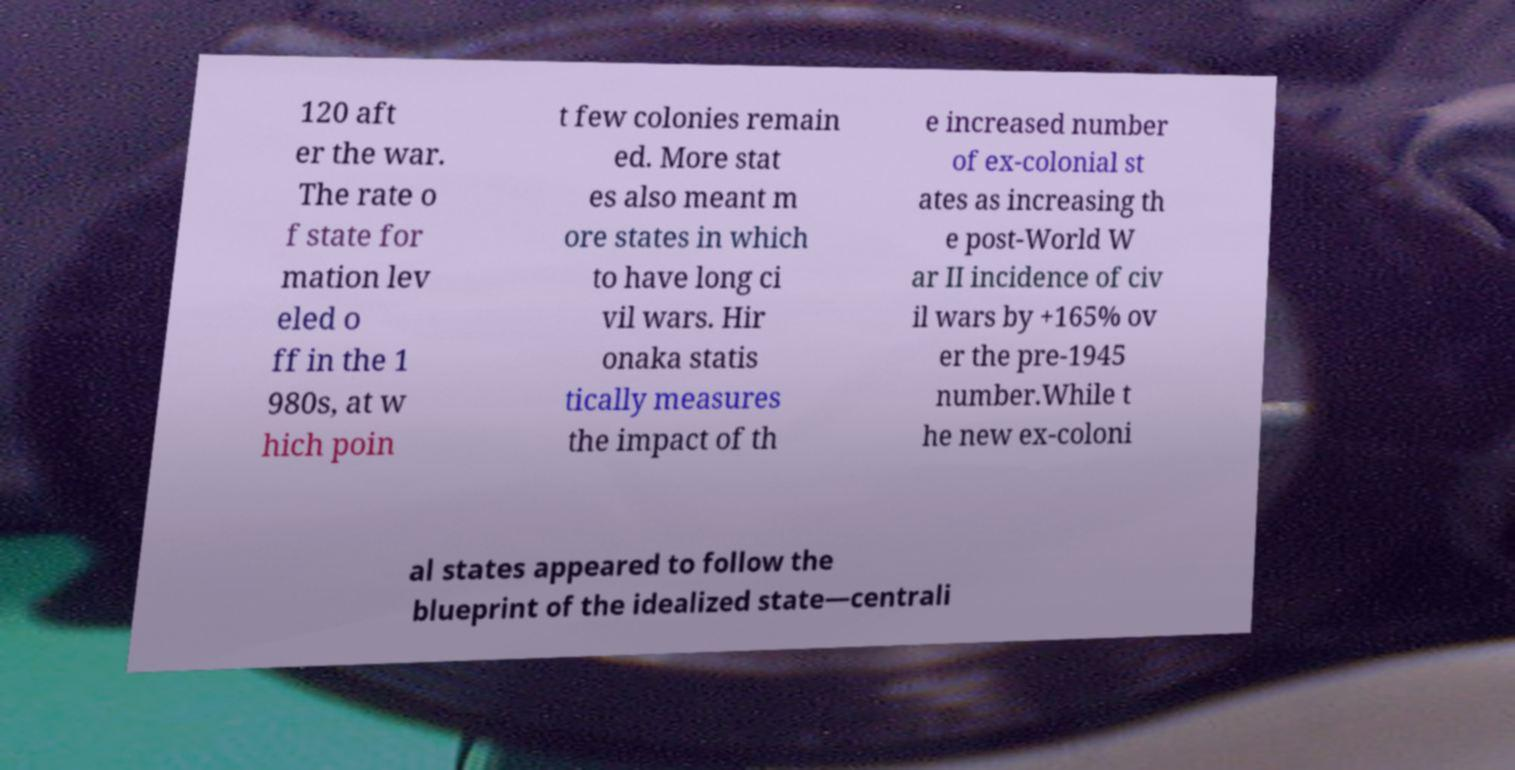Please read and relay the text visible in this image. What does it say? 120 aft er the war. The rate o f state for mation lev eled o ff in the 1 980s, at w hich poin t few colonies remain ed. More stat es also meant m ore states in which to have long ci vil wars. Hir onaka statis tically measures the impact of th e increased number of ex-colonial st ates as increasing th e post-World W ar II incidence of civ il wars by +165% ov er the pre-1945 number.While t he new ex-coloni al states appeared to follow the blueprint of the idealized state—centrali 